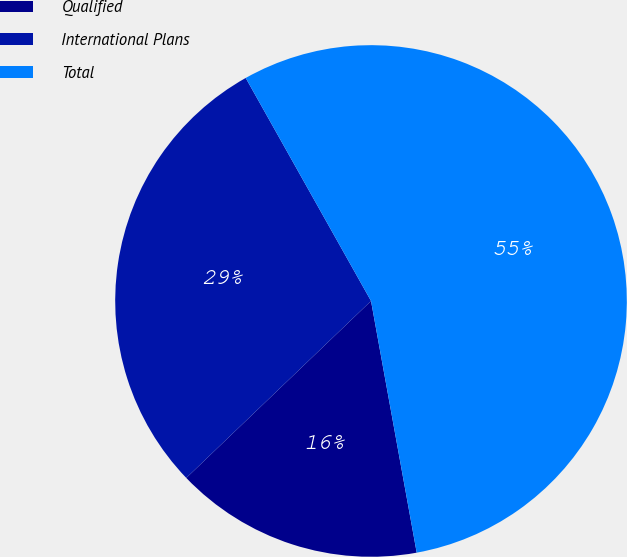<chart> <loc_0><loc_0><loc_500><loc_500><pie_chart><fcel>Qualified<fcel>International Plans<fcel>Total<nl><fcel>15.7%<fcel>29.01%<fcel>55.29%<nl></chart> 